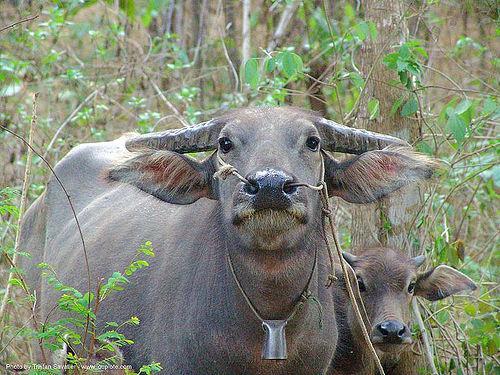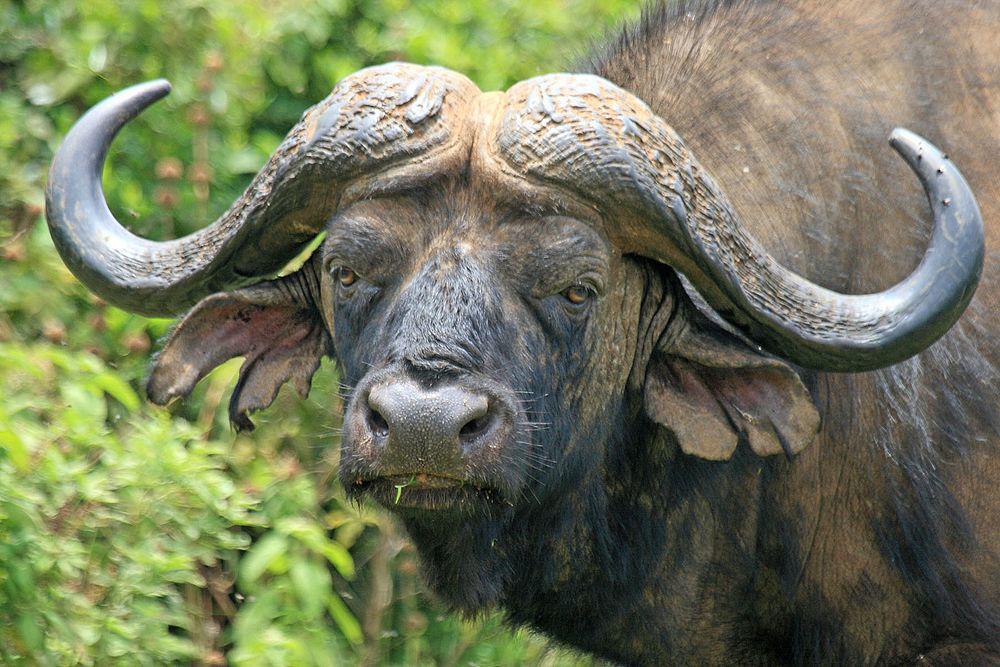The first image is the image on the left, the second image is the image on the right. Evaluate the accuracy of this statement regarding the images: "There are 2 wild cattle.". Is it true? Answer yes or no. No. 